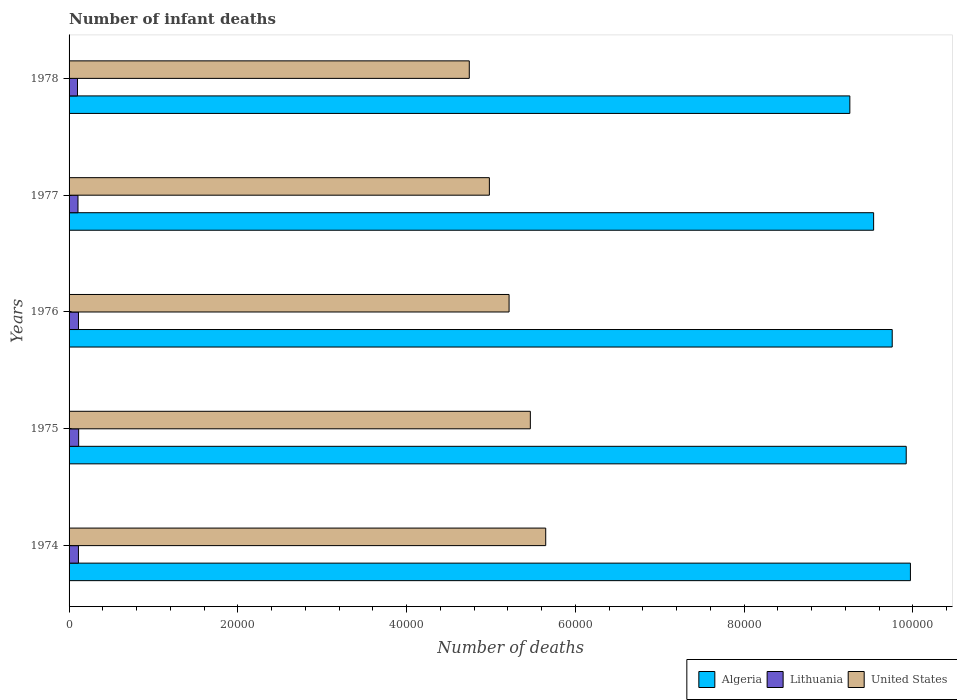Are the number of bars on each tick of the Y-axis equal?
Keep it short and to the point. Yes. How many bars are there on the 3rd tick from the bottom?
Offer a terse response. 3. What is the label of the 3rd group of bars from the top?
Give a very brief answer. 1976. In how many cases, is the number of bars for a given year not equal to the number of legend labels?
Your answer should be compact. 0. What is the number of infant deaths in Lithuania in 1975?
Offer a very short reply. 1136. Across all years, what is the maximum number of infant deaths in Algeria?
Your answer should be compact. 9.97e+04. Across all years, what is the minimum number of infant deaths in United States?
Provide a short and direct response. 4.74e+04. In which year was the number of infant deaths in United States maximum?
Give a very brief answer. 1974. In which year was the number of infant deaths in Lithuania minimum?
Your answer should be compact. 1978. What is the total number of infant deaths in United States in the graph?
Provide a short and direct response. 2.61e+05. What is the difference between the number of infant deaths in Algeria in 1974 and that in 1976?
Ensure brevity in your answer.  2157. What is the difference between the number of infant deaths in United States in 1978 and the number of infant deaths in Algeria in 1974?
Your response must be concise. -5.23e+04. What is the average number of infant deaths in Algeria per year?
Offer a terse response. 9.69e+04. In the year 1978, what is the difference between the number of infant deaths in Algeria and number of infant deaths in United States?
Your answer should be very brief. 4.51e+04. In how many years, is the number of infant deaths in Lithuania greater than 72000 ?
Keep it short and to the point. 0. What is the ratio of the number of infant deaths in United States in 1975 to that in 1976?
Keep it short and to the point. 1.05. Is the difference between the number of infant deaths in Algeria in 1975 and 1978 greater than the difference between the number of infant deaths in United States in 1975 and 1978?
Your answer should be very brief. No. What is the difference between the highest and the second highest number of infant deaths in Lithuania?
Provide a short and direct response. 23. What is the difference between the highest and the lowest number of infant deaths in Algeria?
Provide a short and direct response. 7179. In how many years, is the number of infant deaths in United States greater than the average number of infant deaths in United States taken over all years?
Offer a very short reply. 3. What does the 3rd bar from the top in 1977 represents?
Ensure brevity in your answer.  Algeria. What does the 2nd bar from the bottom in 1974 represents?
Offer a terse response. Lithuania. Is it the case that in every year, the sum of the number of infant deaths in Algeria and number of infant deaths in Lithuania is greater than the number of infant deaths in United States?
Keep it short and to the point. Yes. How many legend labels are there?
Your answer should be compact. 3. How are the legend labels stacked?
Ensure brevity in your answer.  Horizontal. What is the title of the graph?
Your response must be concise. Number of infant deaths. What is the label or title of the X-axis?
Your response must be concise. Number of deaths. What is the Number of deaths of Algeria in 1974?
Offer a very short reply. 9.97e+04. What is the Number of deaths in Lithuania in 1974?
Provide a succinct answer. 1110. What is the Number of deaths of United States in 1974?
Give a very brief answer. 5.65e+04. What is the Number of deaths in Algeria in 1975?
Keep it short and to the point. 9.92e+04. What is the Number of deaths in Lithuania in 1975?
Give a very brief answer. 1136. What is the Number of deaths in United States in 1975?
Provide a short and direct response. 5.47e+04. What is the Number of deaths of Algeria in 1976?
Your response must be concise. 9.75e+04. What is the Number of deaths of Lithuania in 1976?
Keep it short and to the point. 1113. What is the Number of deaths of United States in 1976?
Give a very brief answer. 5.21e+04. What is the Number of deaths in Algeria in 1977?
Your answer should be very brief. 9.53e+04. What is the Number of deaths of Lithuania in 1977?
Make the answer very short. 1057. What is the Number of deaths in United States in 1977?
Your answer should be very brief. 4.98e+04. What is the Number of deaths in Algeria in 1978?
Offer a very short reply. 9.25e+04. What is the Number of deaths of Lithuania in 1978?
Provide a succinct answer. 997. What is the Number of deaths of United States in 1978?
Keep it short and to the point. 4.74e+04. Across all years, what is the maximum Number of deaths of Algeria?
Offer a very short reply. 9.97e+04. Across all years, what is the maximum Number of deaths of Lithuania?
Your answer should be compact. 1136. Across all years, what is the maximum Number of deaths in United States?
Your answer should be very brief. 5.65e+04. Across all years, what is the minimum Number of deaths of Algeria?
Your answer should be very brief. 9.25e+04. Across all years, what is the minimum Number of deaths in Lithuania?
Offer a terse response. 997. Across all years, what is the minimum Number of deaths of United States?
Keep it short and to the point. 4.74e+04. What is the total Number of deaths in Algeria in the graph?
Keep it short and to the point. 4.84e+05. What is the total Number of deaths of Lithuania in the graph?
Your answer should be compact. 5413. What is the total Number of deaths of United States in the graph?
Offer a terse response. 2.61e+05. What is the difference between the Number of deaths in Algeria in 1974 and that in 1975?
Provide a succinct answer. 499. What is the difference between the Number of deaths in Lithuania in 1974 and that in 1975?
Offer a terse response. -26. What is the difference between the Number of deaths of United States in 1974 and that in 1975?
Your answer should be very brief. 1821. What is the difference between the Number of deaths of Algeria in 1974 and that in 1976?
Your response must be concise. 2157. What is the difference between the Number of deaths of United States in 1974 and that in 1976?
Your answer should be very brief. 4342. What is the difference between the Number of deaths of Algeria in 1974 and that in 1977?
Provide a short and direct response. 4360. What is the difference between the Number of deaths of United States in 1974 and that in 1977?
Provide a succinct answer. 6676. What is the difference between the Number of deaths in Algeria in 1974 and that in 1978?
Make the answer very short. 7179. What is the difference between the Number of deaths of Lithuania in 1974 and that in 1978?
Provide a short and direct response. 113. What is the difference between the Number of deaths in United States in 1974 and that in 1978?
Give a very brief answer. 9057. What is the difference between the Number of deaths in Algeria in 1975 and that in 1976?
Your answer should be compact. 1658. What is the difference between the Number of deaths of United States in 1975 and that in 1976?
Your answer should be compact. 2521. What is the difference between the Number of deaths in Algeria in 1975 and that in 1977?
Give a very brief answer. 3861. What is the difference between the Number of deaths of Lithuania in 1975 and that in 1977?
Provide a succinct answer. 79. What is the difference between the Number of deaths in United States in 1975 and that in 1977?
Ensure brevity in your answer.  4855. What is the difference between the Number of deaths in Algeria in 1975 and that in 1978?
Make the answer very short. 6680. What is the difference between the Number of deaths of Lithuania in 1975 and that in 1978?
Your answer should be compact. 139. What is the difference between the Number of deaths in United States in 1975 and that in 1978?
Give a very brief answer. 7236. What is the difference between the Number of deaths in Algeria in 1976 and that in 1977?
Provide a short and direct response. 2203. What is the difference between the Number of deaths of United States in 1976 and that in 1977?
Offer a very short reply. 2334. What is the difference between the Number of deaths of Algeria in 1976 and that in 1978?
Offer a terse response. 5022. What is the difference between the Number of deaths in Lithuania in 1976 and that in 1978?
Offer a terse response. 116. What is the difference between the Number of deaths in United States in 1976 and that in 1978?
Your response must be concise. 4715. What is the difference between the Number of deaths in Algeria in 1977 and that in 1978?
Provide a short and direct response. 2819. What is the difference between the Number of deaths in United States in 1977 and that in 1978?
Make the answer very short. 2381. What is the difference between the Number of deaths of Algeria in 1974 and the Number of deaths of Lithuania in 1975?
Give a very brief answer. 9.86e+04. What is the difference between the Number of deaths in Algeria in 1974 and the Number of deaths in United States in 1975?
Keep it short and to the point. 4.50e+04. What is the difference between the Number of deaths in Lithuania in 1974 and the Number of deaths in United States in 1975?
Your answer should be very brief. -5.36e+04. What is the difference between the Number of deaths in Algeria in 1974 and the Number of deaths in Lithuania in 1976?
Your answer should be very brief. 9.86e+04. What is the difference between the Number of deaths of Algeria in 1974 and the Number of deaths of United States in 1976?
Your answer should be compact. 4.76e+04. What is the difference between the Number of deaths in Lithuania in 1974 and the Number of deaths in United States in 1976?
Make the answer very short. -5.10e+04. What is the difference between the Number of deaths in Algeria in 1974 and the Number of deaths in Lithuania in 1977?
Keep it short and to the point. 9.86e+04. What is the difference between the Number of deaths of Algeria in 1974 and the Number of deaths of United States in 1977?
Provide a short and direct response. 4.99e+04. What is the difference between the Number of deaths in Lithuania in 1974 and the Number of deaths in United States in 1977?
Your response must be concise. -4.87e+04. What is the difference between the Number of deaths in Algeria in 1974 and the Number of deaths in Lithuania in 1978?
Keep it short and to the point. 9.87e+04. What is the difference between the Number of deaths of Algeria in 1974 and the Number of deaths of United States in 1978?
Ensure brevity in your answer.  5.23e+04. What is the difference between the Number of deaths of Lithuania in 1974 and the Number of deaths of United States in 1978?
Provide a short and direct response. -4.63e+04. What is the difference between the Number of deaths in Algeria in 1975 and the Number of deaths in Lithuania in 1976?
Ensure brevity in your answer.  9.81e+04. What is the difference between the Number of deaths in Algeria in 1975 and the Number of deaths in United States in 1976?
Provide a succinct answer. 4.71e+04. What is the difference between the Number of deaths in Lithuania in 1975 and the Number of deaths in United States in 1976?
Keep it short and to the point. -5.10e+04. What is the difference between the Number of deaths in Algeria in 1975 and the Number of deaths in Lithuania in 1977?
Provide a short and direct response. 9.81e+04. What is the difference between the Number of deaths of Algeria in 1975 and the Number of deaths of United States in 1977?
Provide a succinct answer. 4.94e+04. What is the difference between the Number of deaths in Lithuania in 1975 and the Number of deaths in United States in 1977?
Your answer should be compact. -4.87e+04. What is the difference between the Number of deaths of Algeria in 1975 and the Number of deaths of Lithuania in 1978?
Your answer should be compact. 9.82e+04. What is the difference between the Number of deaths in Algeria in 1975 and the Number of deaths in United States in 1978?
Make the answer very short. 5.18e+04. What is the difference between the Number of deaths of Lithuania in 1975 and the Number of deaths of United States in 1978?
Your response must be concise. -4.63e+04. What is the difference between the Number of deaths of Algeria in 1976 and the Number of deaths of Lithuania in 1977?
Make the answer very short. 9.65e+04. What is the difference between the Number of deaths in Algeria in 1976 and the Number of deaths in United States in 1977?
Offer a terse response. 4.77e+04. What is the difference between the Number of deaths in Lithuania in 1976 and the Number of deaths in United States in 1977?
Offer a terse response. -4.87e+04. What is the difference between the Number of deaths of Algeria in 1976 and the Number of deaths of Lithuania in 1978?
Your answer should be very brief. 9.65e+04. What is the difference between the Number of deaths in Algeria in 1976 and the Number of deaths in United States in 1978?
Provide a short and direct response. 5.01e+04. What is the difference between the Number of deaths in Lithuania in 1976 and the Number of deaths in United States in 1978?
Keep it short and to the point. -4.63e+04. What is the difference between the Number of deaths in Algeria in 1977 and the Number of deaths in Lithuania in 1978?
Ensure brevity in your answer.  9.43e+04. What is the difference between the Number of deaths in Algeria in 1977 and the Number of deaths in United States in 1978?
Provide a short and direct response. 4.79e+04. What is the difference between the Number of deaths of Lithuania in 1977 and the Number of deaths of United States in 1978?
Your answer should be very brief. -4.64e+04. What is the average Number of deaths in Algeria per year?
Offer a very short reply. 9.69e+04. What is the average Number of deaths of Lithuania per year?
Your answer should be very brief. 1082.6. What is the average Number of deaths of United States per year?
Keep it short and to the point. 5.21e+04. In the year 1974, what is the difference between the Number of deaths of Algeria and Number of deaths of Lithuania?
Your answer should be very brief. 9.86e+04. In the year 1974, what is the difference between the Number of deaths in Algeria and Number of deaths in United States?
Give a very brief answer. 4.32e+04. In the year 1974, what is the difference between the Number of deaths of Lithuania and Number of deaths of United States?
Your response must be concise. -5.54e+04. In the year 1975, what is the difference between the Number of deaths in Algeria and Number of deaths in Lithuania?
Your response must be concise. 9.81e+04. In the year 1975, what is the difference between the Number of deaths of Algeria and Number of deaths of United States?
Offer a very short reply. 4.45e+04. In the year 1975, what is the difference between the Number of deaths of Lithuania and Number of deaths of United States?
Your answer should be compact. -5.35e+04. In the year 1976, what is the difference between the Number of deaths in Algeria and Number of deaths in Lithuania?
Offer a terse response. 9.64e+04. In the year 1976, what is the difference between the Number of deaths in Algeria and Number of deaths in United States?
Keep it short and to the point. 4.54e+04. In the year 1976, what is the difference between the Number of deaths in Lithuania and Number of deaths in United States?
Give a very brief answer. -5.10e+04. In the year 1977, what is the difference between the Number of deaths in Algeria and Number of deaths in Lithuania?
Keep it short and to the point. 9.43e+04. In the year 1977, what is the difference between the Number of deaths of Algeria and Number of deaths of United States?
Your answer should be very brief. 4.55e+04. In the year 1977, what is the difference between the Number of deaths in Lithuania and Number of deaths in United States?
Your response must be concise. -4.88e+04. In the year 1978, what is the difference between the Number of deaths of Algeria and Number of deaths of Lithuania?
Make the answer very short. 9.15e+04. In the year 1978, what is the difference between the Number of deaths in Algeria and Number of deaths in United States?
Your answer should be very brief. 4.51e+04. In the year 1978, what is the difference between the Number of deaths of Lithuania and Number of deaths of United States?
Your answer should be compact. -4.64e+04. What is the ratio of the Number of deaths in Lithuania in 1974 to that in 1975?
Offer a terse response. 0.98. What is the ratio of the Number of deaths in United States in 1974 to that in 1975?
Give a very brief answer. 1.03. What is the ratio of the Number of deaths of Algeria in 1974 to that in 1976?
Your response must be concise. 1.02. What is the ratio of the Number of deaths in Lithuania in 1974 to that in 1976?
Offer a terse response. 1. What is the ratio of the Number of deaths in United States in 1974 to that in 1976?
Ensure brevity in your answer.  1.08. What is the ratio of the Number of deaths in Algeria in 1974 to that in 1977?
Your response must be concise. 1.05. What is the ratio of the Number of deaths of Lithuania in 1974 to that in 1977?
Provide a succinct answer. 1.05. What is the ratio of the Number of deaths of United States in 1974 to that in 1977?
Give a very brief answer. 1.13. What is the ratio of the Number of deaths in Algeria in 1974 to that in 1978?
Give a very brief answer. 1.08. What is the ratio of the Number of deaths in Lithuania in 1974 to that in 1978?
Provide a short and direct response. 1.11. What is the ratio of the Number of deaths of United States in 1974 to that in 1978?
Your response must be concise. 1.19. What is the ratio of the Number of deaths in Lithuania in 1975 to that in 1976?
Your answer should be compact. 1.02. What is the ratio of the Number of deaths of United States in 1975 to that in 1976?
Offer a very short reply. 1.05. What is the ratio of the Number of deaths of Algeria in 1975 to that in 1977?
Ensure brevity in your answer.  1.04. What is the ratio of the Number of deaths of Lithuania in 1975 to that in 1977?
Give a very brief answer. 1.07. What is the ratio of the Number of deaths of United States in 1975 to that in 1977?
Provide a short and direct response. 1.1. What is the ratio of the Number of deaths in Algeria in 1975 to that in 1978?
Your response must be concise. 1.07. What is the ratio of the Number of deaths in Lithuania in 1975 to that in 1978?
Your response must be concise. 1.14. What is the ratio of the Number of deaths in United States in 1975 to that in 1978?
Ensure brevity in your answer.  1.15. What is the ratio of the Number of deaths in Algeria in 1976 to that in 1977?
Your answer should be very brief. 1.02. What is the ratio of the Number of deaths of Lithuania in 1976 to that in 1977?
Your answer should be very brief. 1.05. What is the ratio of the Number of deaths in United States in 1976 to that in 1977?
Give a very brief answer. 1.05. What is the ratio of the Number of deaths of Algeria in 1976 to that in 1978?
Offer a terse response. 1.05. What is the ratio of the Number of deaths in Lithuania in 1976 to that in 1978?
Your answer should be compact. 1.12. What is the ratio of the Number of deaths of United States in 1976 to that in 1978?
Keep it short and to the point. 1.1. What is the ratio of the Number of deaths of Algeria in 1977 to that in 1978?
Give a very brief answer. 1.03. What is the ratio of the Number of deaths in Lithuania in 1977 to that in 1978?
Your response must be concise. 1.06. What is the ratio of the Number of deaths of United States in 1977 to that in 1978?
Keep it short and to the point. 1.05. What is the difference between the highest and the second highest Number of deaths of Algeria?
Offer a terse response. 499. What is the difference between the highest and the second highest Number of deaths of Lithuania?
Your answer should be compact. 23. What is the difference between the highest and the second highest Number of deaths of United States?
Give a very brief answer. 1821. What is the difference between the highest and the lowest Number of deaths of Algeria?
Provide a short and direct response. 7179. What is the difference between the highest and the lowest Number of deaths in Lithuania?
Make the answer very short. 139. What is the difference between the highest and the lowest Number of deaths of United States?
Provide a succinct answer. 9057. 